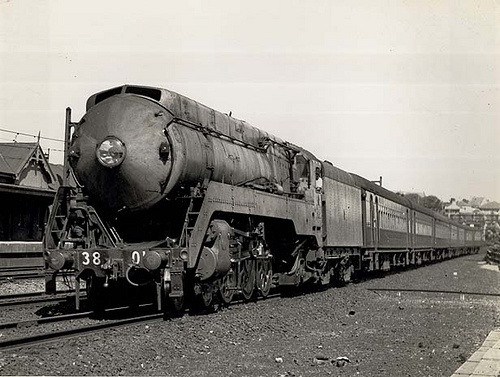Describe the objects in this image and their specific colors. I can see train in lightgray, black, gray, and darkgray tones and people in lightgray, black, gray, and darkgray tones in this image. 